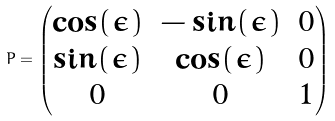Convert formula to latex. <formula><loc_0><loc_0><loc_500><loc_500>P = \begin{pmatrix} \cos ( \epsilon ) & - \sin ( \epsilon ) & 0 \\ \sin ( \epsilon ) & \cos ( \epsilon ) & 0 \\ 0 & 0 & 1 \end{pmatrix}</formula> 